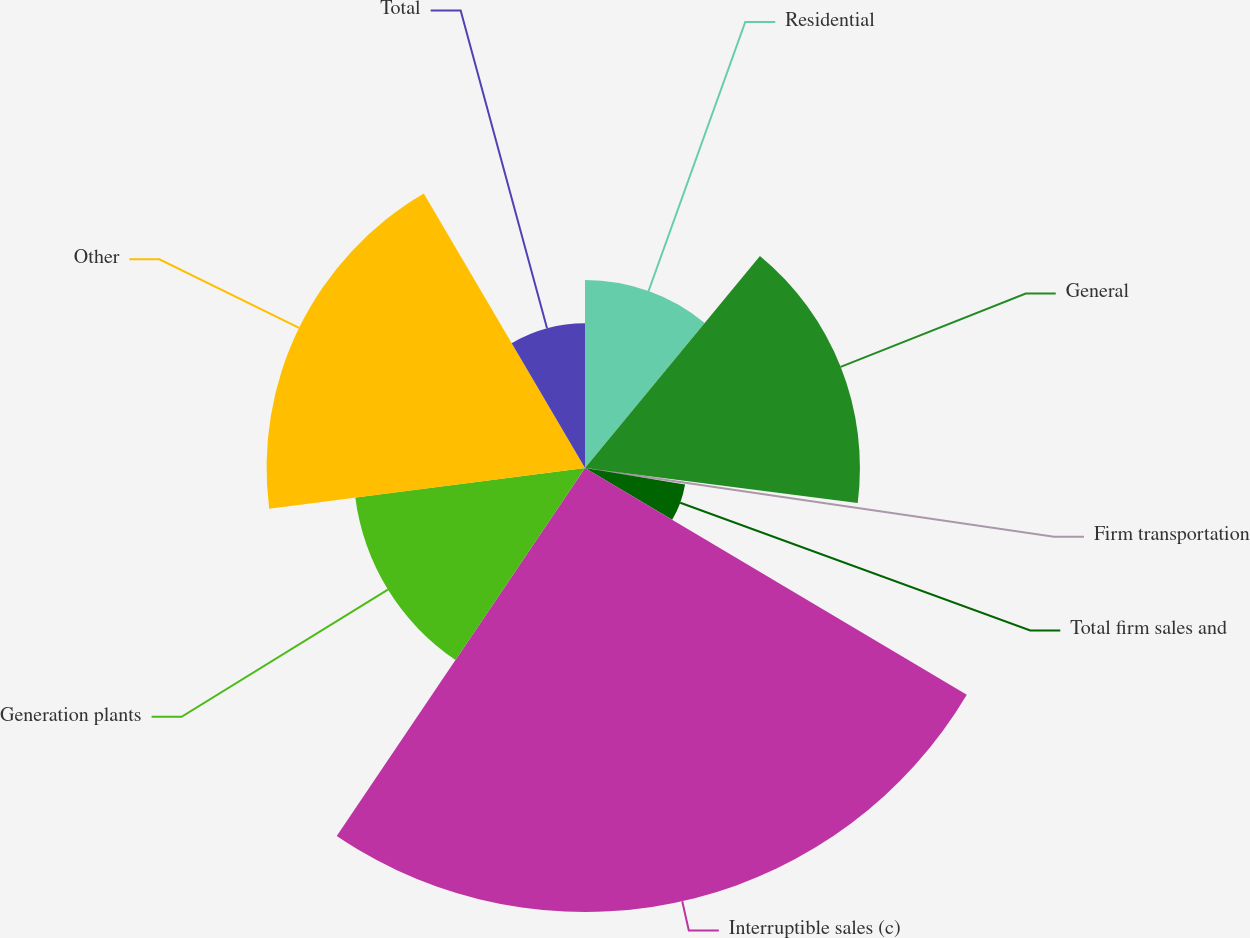<chart> <loc_0><loc_0><loc_500><loc_500><pie_chart><fcel>Residential<fcel>General<fcel>Firm transportation<fcel>Total firm sales and<fcel>Interruptible sales (c)<fcel>Generation plants<fcel>Other<fcel>Total<nl><fcel>10.98%<fcel>16.05%<fcel>0.58%<fcel>5.92%<fcel>25.92%<fcel>13.52%<fcel>18.59%<fcel>8.45%<nl></chart> 